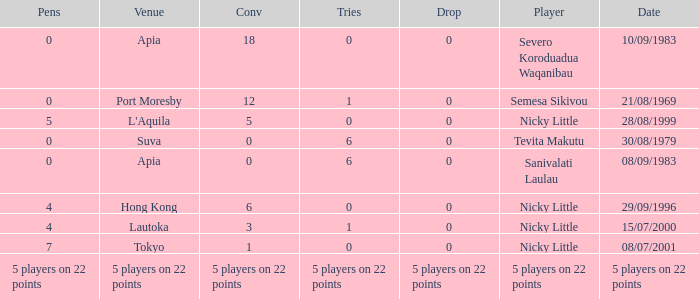How many conversions did Severo Koroduadua Waqanibau have when he has 0 pens? 18.0. 